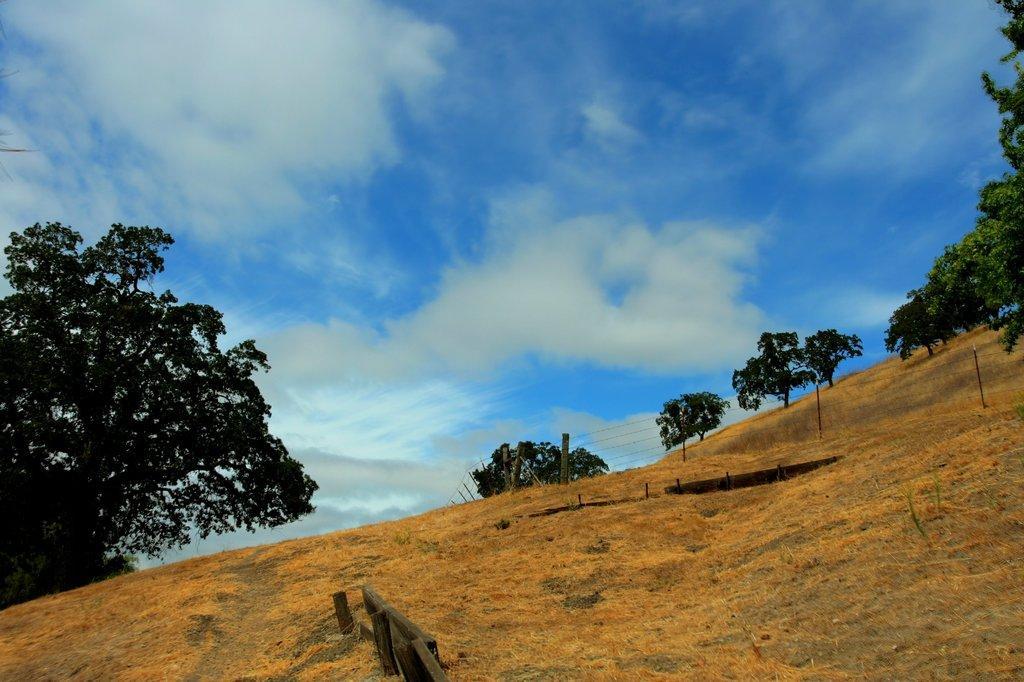How would you summarize this image in a sentence or two? In this image there are trees present on the mountain. In the background there is sky with clouds. 